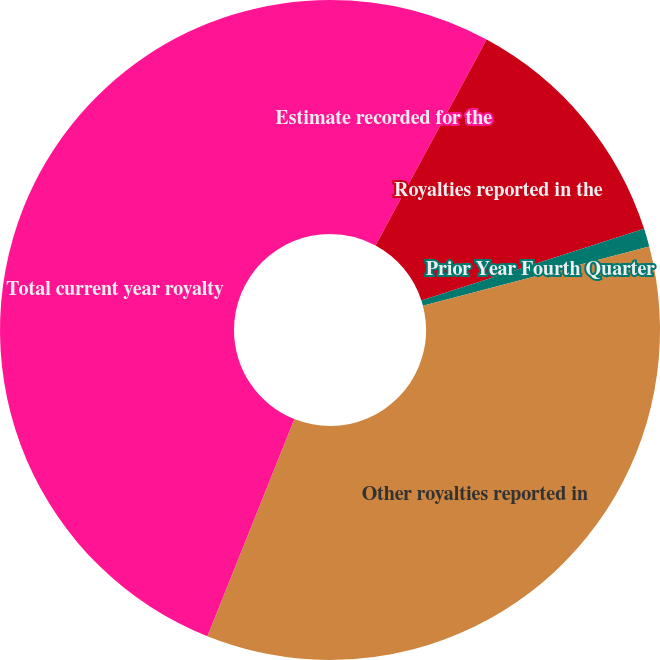Convert chart. <chart><loc_0><loc_0><loc_500><loc_500><pie_chart><fcel>Estimate recorded for the<fcel>Royalties reported in the<fcel>Prior Year Fourth Quarter<fcel>Other royalties reported in<fcel>Total current year royalty<nl><fcel>7.87%<fcel>12.17%<fcel>0.89%<fcel>35.13%<fcel>43.94%<nl></chart> 